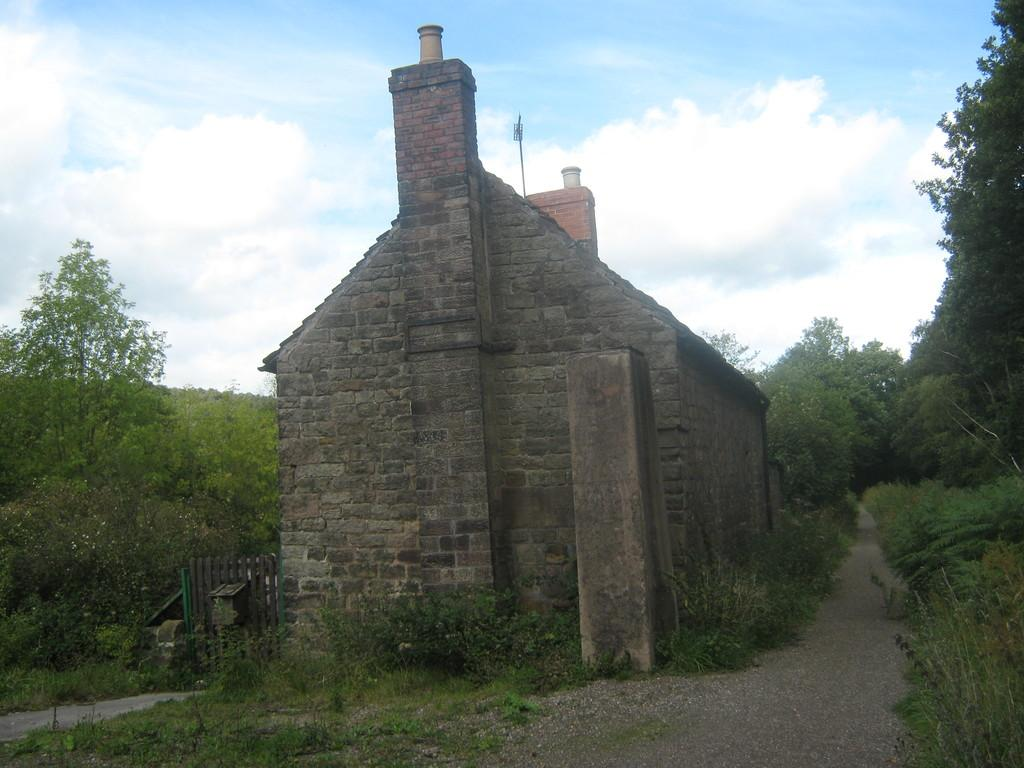What is the main feature of the image? There is a road in the image. What can be seen on both sides of the road? There are trees on both sides of the road. What type of building is visible in the image? There is a huge building made of bricks in the image. How close is the building to the road? The building is near the road. What is visible in the background of the image? There are trees and the sky in the background of the image. What type of jam is being spread on the hand in the image? There is no jam or hand present in the image; it features a road, trees, and a brick building. 